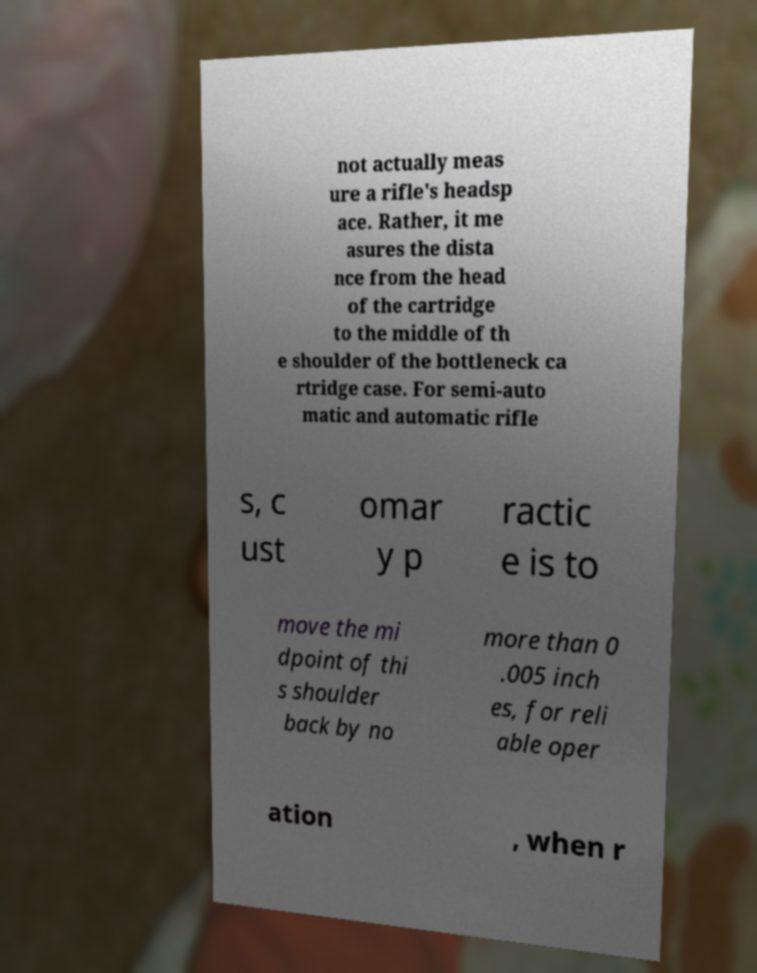Could you extract and type out the text from this image? not actually meas ure a rifle's headsp ace. Rather, it me asures the dista nce from the head of the cartridge to the middle of th e shoulder of the bottleneck ca rtridge case. For semi-auto matic and automatic rifle s, c ust omar y p ractic e is to move the mi dpoint of thi s shoulder back by no more than 0 .005 inch es, for reli able oper ation , when r 